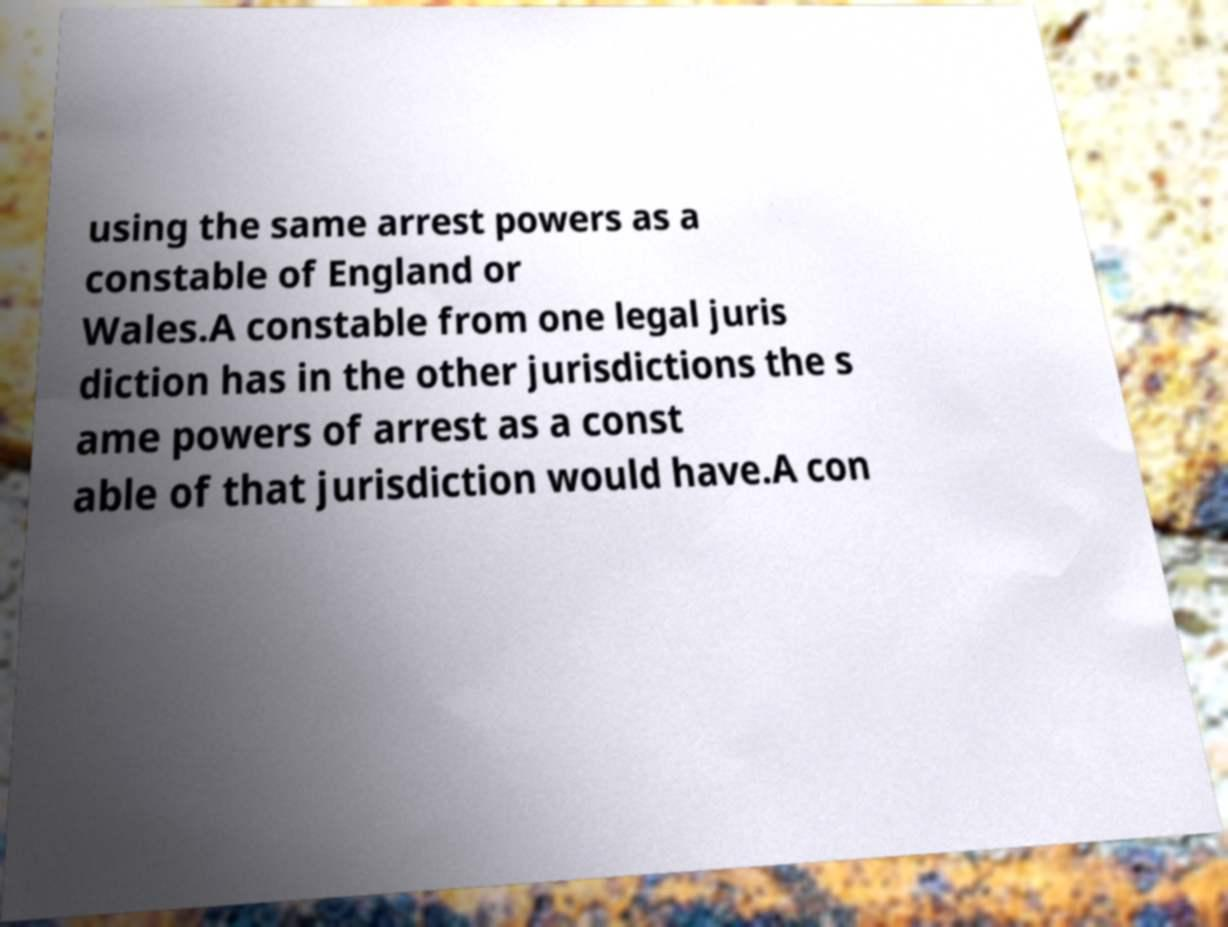For documentation purposes, I need the text within this image transcribed. Could you provide that? using the same arrest powers as a constable of England or Wales.A constable from one legal juris diction has in the other jurisdictions the s ame powers of arrest as a const able of that jurisdiction would have.A con 